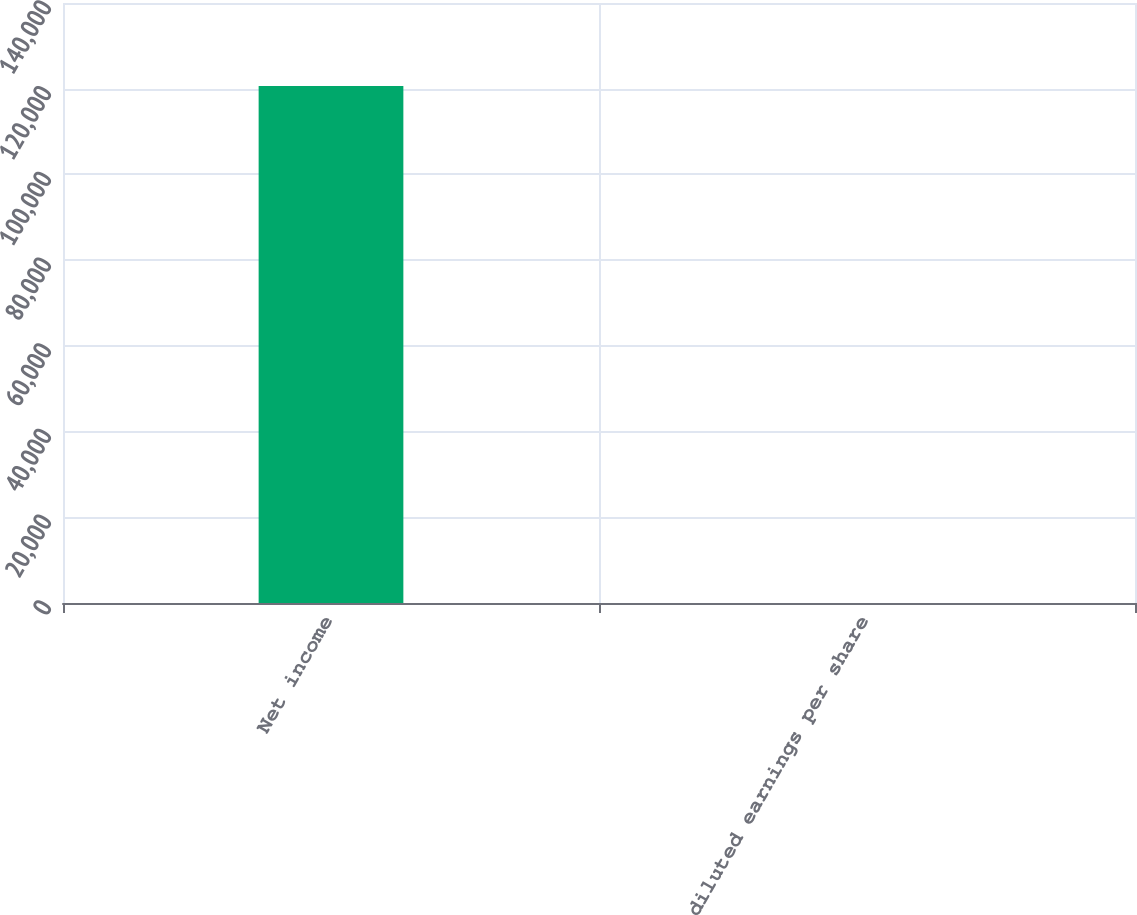<chart> <loc_0><loc_0><loc_500><loc_500><bar_chart><fcel>Net income<fcel>diluted earnings per share<nl><fcel>120643<fcel>1.66<nl></chart> 